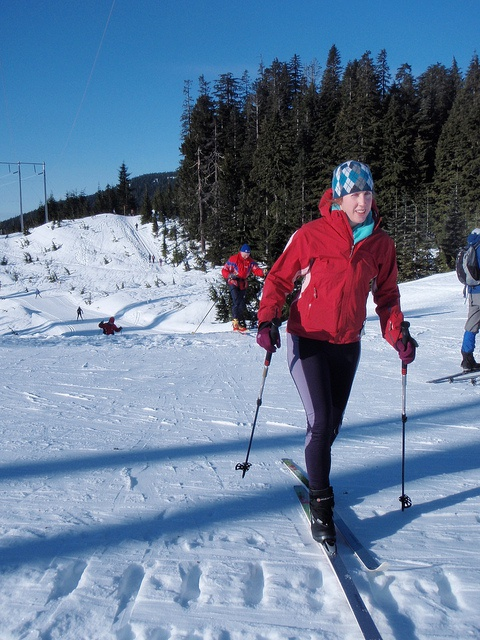Describe the objects in this image and their specific colors. I can see people in blue, black, maroon, and brown tones, skis in blue, darkblue, navy, lightgray, and gray tones, people in blue, black, brown, maroon, and navy tones, people in blue, black, navy, and gray tones, and backpack in blue, black, gray, and darkgray tones in this image. 